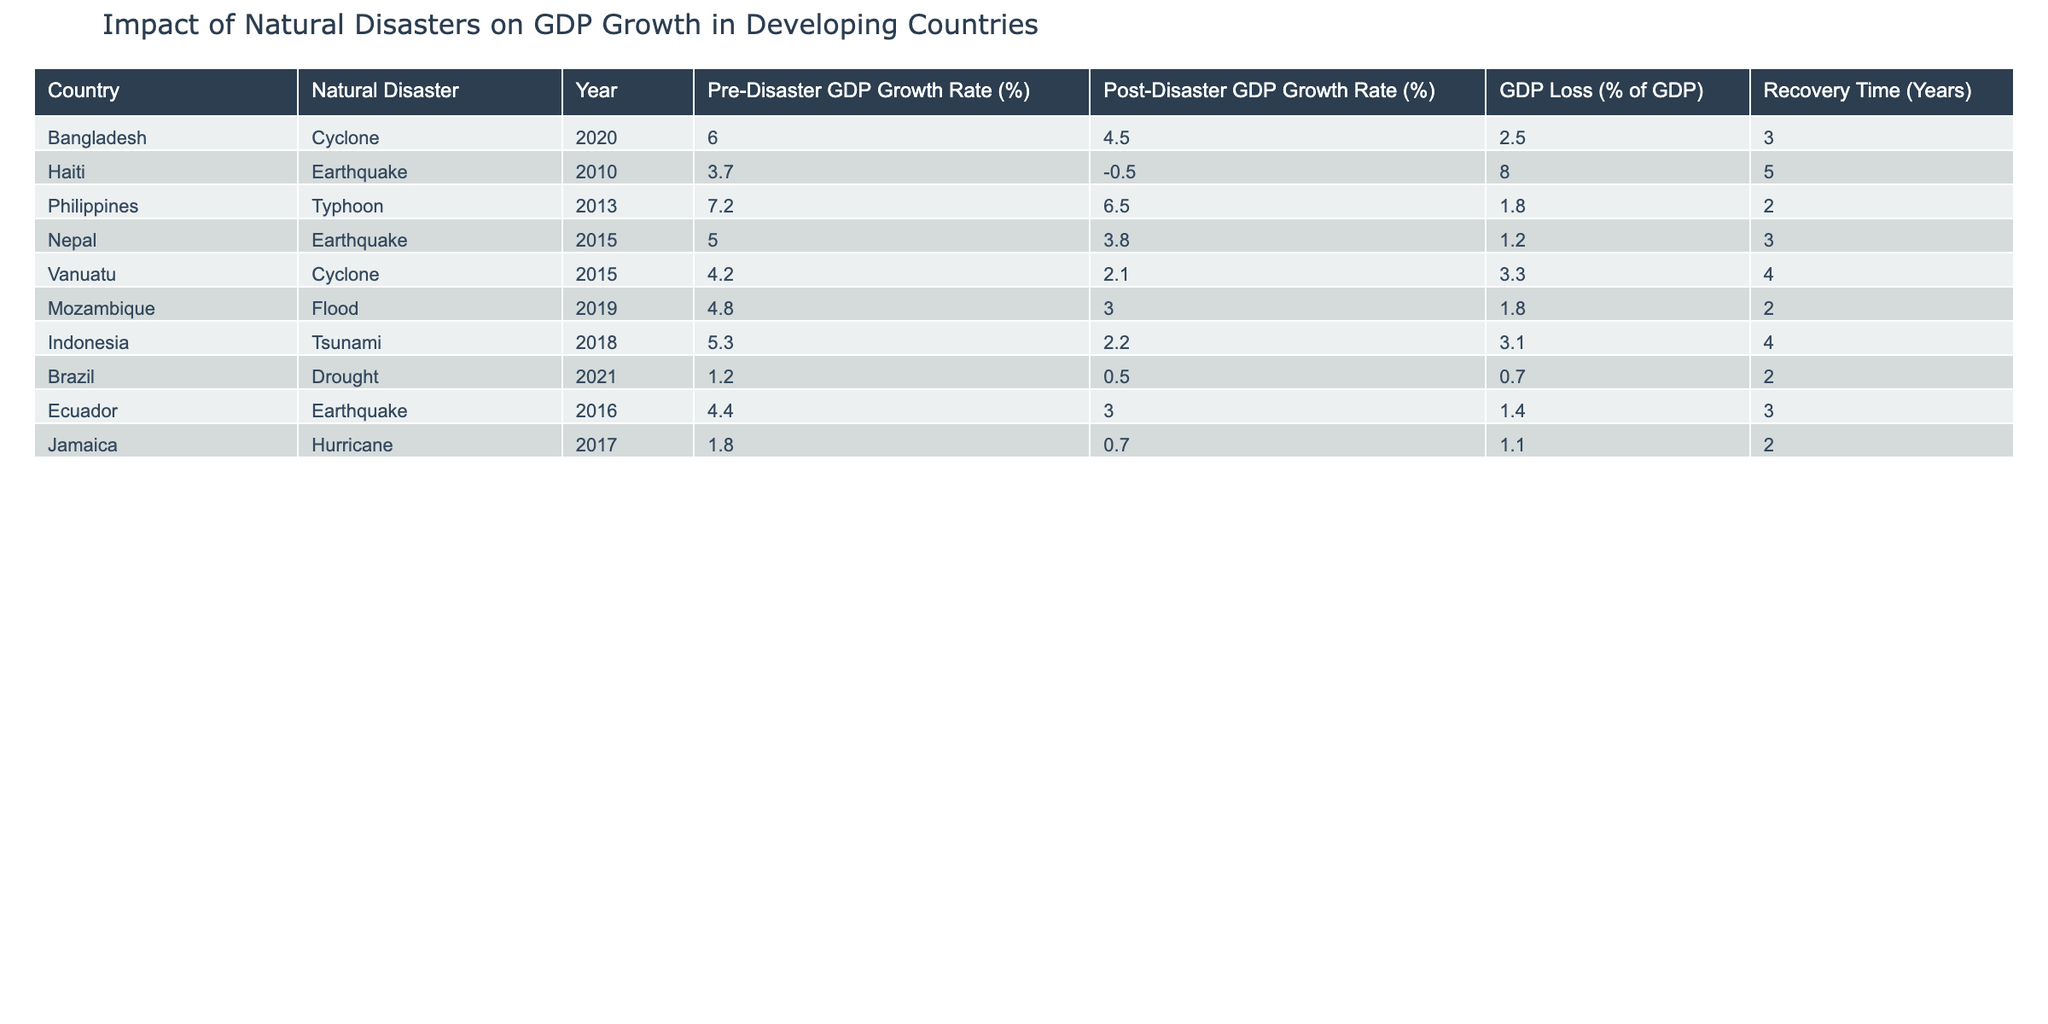What is the GDP loss percentage for Haiti after the earthquake in 2010? From the row corresponding to Haiti's earthquake, the GDP loss is listed as 8.0%, which directly answers the question.
Answer: 8.0% Which country experienced the longest recovery time after a natural disaster, and what was the duration? By comparing the recovery times listed in the table, Haiti has the longest recovery time of 5 years.
Answer: Haiti, 5 years What was the average pre-disaster GDP growth rate for the countries listed in the table? The pre-disaster GDP growth rates to calculate the average are: 6.0, 3.7, 7.2, 5.0, 4.2, 4.8, 5.3, 1.2, 4.4, 1.8. The sum is 44.4 and dividing by the 10 countries gives an average of 4.44%.
Answer: 4.44% After the cyclone in Vanuatu in 2015, what was the change in GDP growth rate? The pre-disaster GDP growth rate was 4.2%, and the post-disaster rate was 2.1%. The change is calculated as 2.1 - 4.2 = -2.1%, indicating a decline.
Answer: -2.1% Is the post-disaster GDP growth rate for Brazil higher than for Mozambique? Brazil's post-disaster GDP growth rate is 0.5%, while Mozambique's is 3.0%. Since 0.5% is less than 3.0%, the statement is false.
Answer: No 